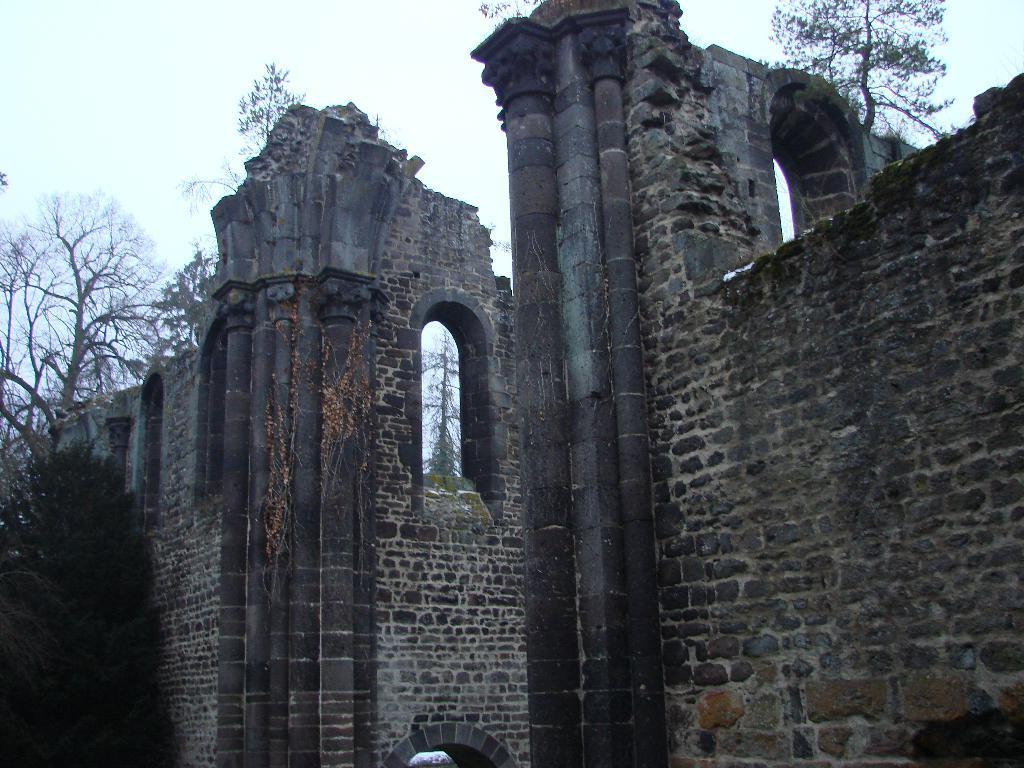How would you summarize this image in a sentence or two? In this picture we can see walls, windows and trees. In the background of the image we can see the sky. 